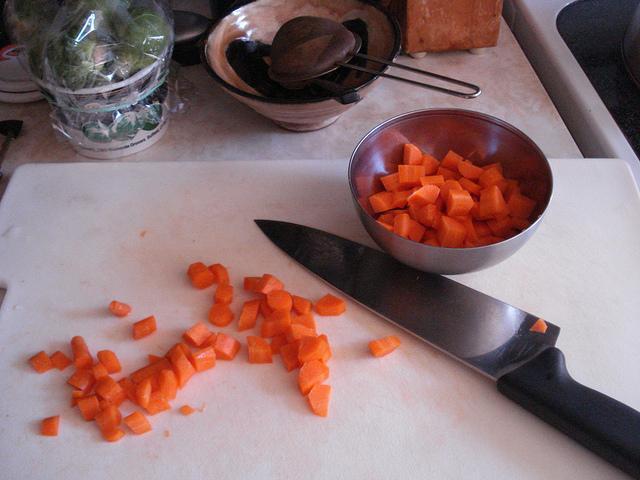How many bowls are there?
Give a very brief answer. 3. How many carrots are visible?
Give a very brief answer. 3. 